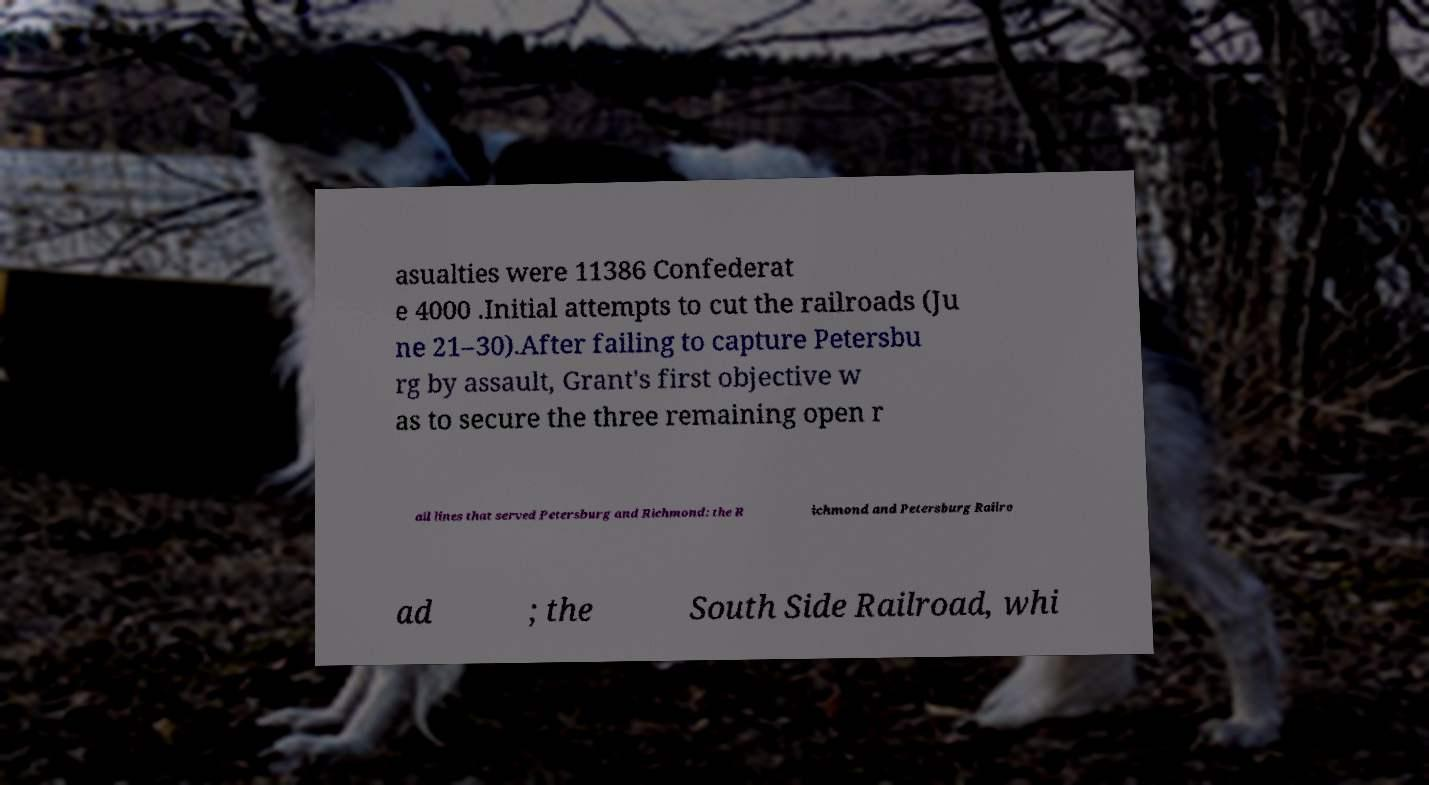Could you extract and type out the text from this image? asualties were 11386 Confederat e 4000 .Initial attempts to cut the railroads (Ju ne 21–30).After failing to capture Petersbu rg by assault, Grant's first objective w as to secure the three remaining open r ail lines that served Petersburg and Richmond: the R ichmond and Petersburg Railro ad ; the South Side Railroad, whi 